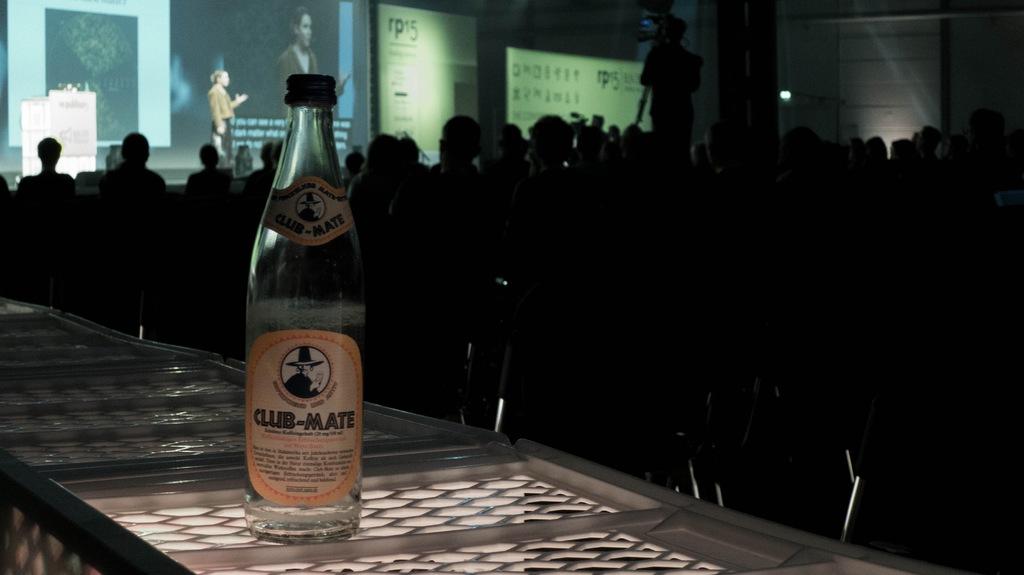What brand is on the bottle?
Give a very brief answer. Club-mate. 